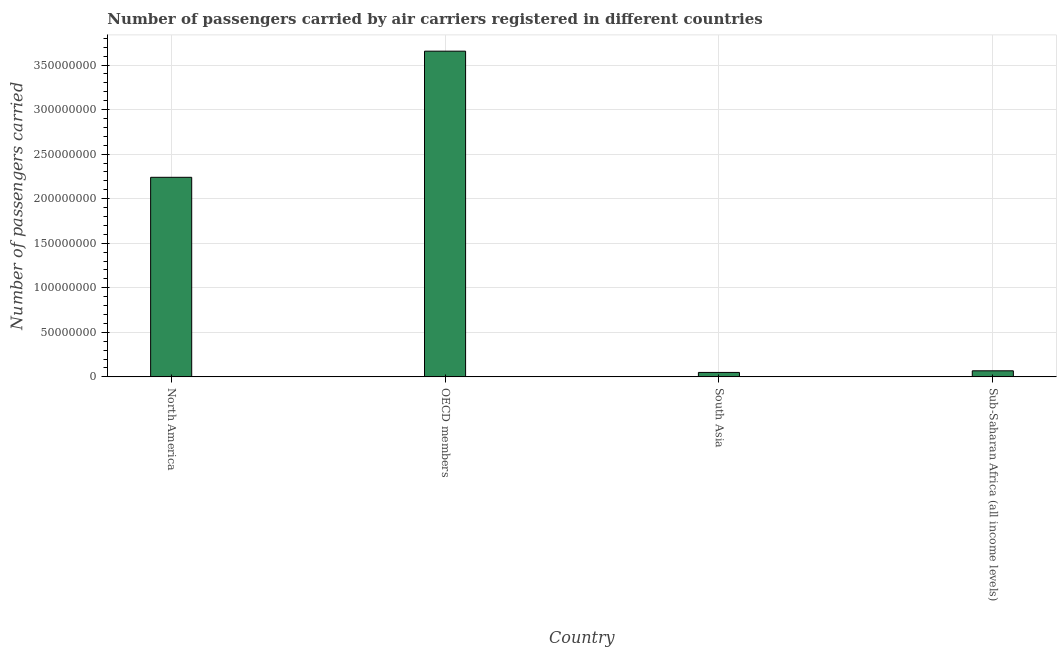Does the graph contain any zero values?
Give a very brief answer. No. What is the title of the graph?
Make the answer very short. Number of passengers carried by air carriers registered in different countries. What is the label or title of the X-axis?
Your response must be concise. Country. What is the label or title of the Y-axis?
Keep it short and to the point. Number of passengers carried. What is the number of passengers carried in OECD members?
Keep it short and to the point. 3.66e+08. Across all countries, what is the maximum number of passengers carried?
Your response must be concise. 3.66e+08. Across all countries, what is the minimum number of passengers carried?
Offer a terse response. 4.98e+06. In which country was the number of passengers carried maximum?
Provide a succinct answer. OECD members. In which country was the number of passengers carried minimum?
Provide a short and direct response. South Asia. What is the sum of the number of passengers carried?
Make the answer very short. 6.01e+08. What is the difference between the number of passengers carried in North America and South Asia?
Your response must be concise. 2.19e+08. What is the average number of passengers carried per country?
Ensure brevity in your answer.  1.50e+08. What is the median number of passengers carried?
Keep it short and to the point. 1.15e+08. What is the ratio of the number of passengers carried in South Asia to that in Sub-Saharan Africa (all income levels)?
Ensure brevity in your answer.  0.73. What is the difference between the highest and the second highest number of passengers carried?
Offer a terse response. 1.42e+08. Is the sum of the number of passengers carried in OECD members and South Asia greater than the maximum number of passengers carried across all countries?
Ensure brevity in your answer.  Yes. What is the difference between the highest and the lowest number of passengers carried?
Offer a terse response. 3.61e+08. In how many countries, is the number of passengers carried greater than the average number of passengers carried taken over all countries?
Give a very brief answer. 2. Are all the bars in the graph horizontal?
Provide a succinct answer. No. Are the values on the major ticks of Y-axis written in scientific E-notation?
Your answer should be compact. No. What is the Number of passengers carried of North America?
Make the answer very short. 2.24e+08. What is the Number of passengers carried in OECD members?
Provide a succinct answer. 3.66e+08. What is the Number of passengers carried of South Asia?
Offer a terse response. 4.98e+06. What is the Number of passengers carried in Sub-Saharan Africa (all income levels)?
Offer a very short reply. 6.81e+06. What is the difference between the Number of passengers carried in North America and OECD members?
Make the answer very short. -1.42e+08. What is the difference between the Number of passengers carried in North America and South Asia?
Your answer should be compact. 2.19e+08. What is the difference between the Number of passengers carried in North America and Sub-Saharan Africa (all income levels)?
Provide a short and direct response. 2.17e+08. What is the difference between the Number of passengers carried in OECD members and South Asia?
Provide a succinct answer. 3.61e+08. What is the difference between the Number of passengers carried in OECD members and Sub-Saharan Africa (all income levels)?
Your answer should be compact. 3.59e+08. What is the difference between the Number of passengers carried in South Asia and Sub-Saharan Africa (all income levels)?
Provide a succinct answer. -1.83e+06. What is the ratio of the Number of passengers carried in North America to that in OECD members?
Give a very brief answer. 0.61. What is the ratio of the Number of passengers carried in North America to that in South Asia?
Ensure brevity in your answer.  44.95. What is the ratio of the Number of passengers carried in North America to that in Sub-Saharan Africa (all income levels)?
Ensure brevity in your answer.  32.88. What is the ratio of the Number of passengers carried in OECD members to that in South Asia?
Give a very brief answer. 73.36. What is the ratio of the Number of passengers carried in OECD members to that in Sub-Saharan Africa (all income levels)?
Make the answer very short. 53.66. What is the ratio of the Number of passengers carried in South Asia to that in Sub-Saharan Africa (all income levels)?
Make the answer very short. 0.73. 